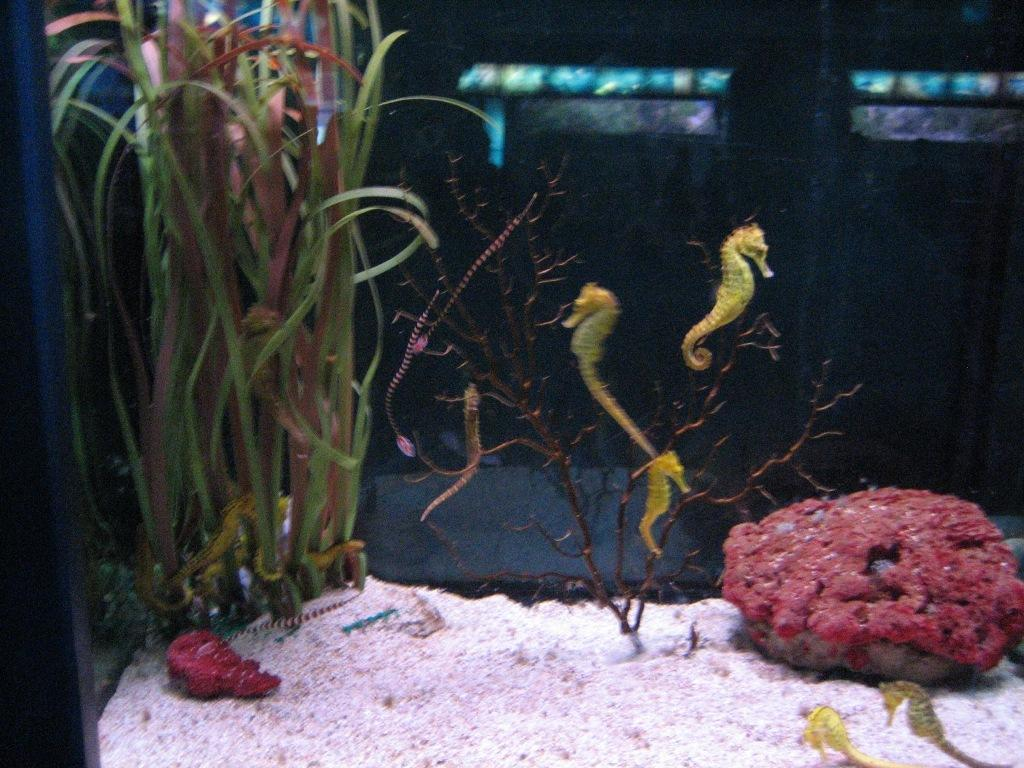What type of living organisms can be seen in the image? Plants can be seen in the image. What color are the flowers on the plants in the image? The flowers on the plants in the image are red. What type of soap is being used to clean the flowers in the image? There is no soap or cleaning activity depicted in the image; it simply shows plants with red flowers. 